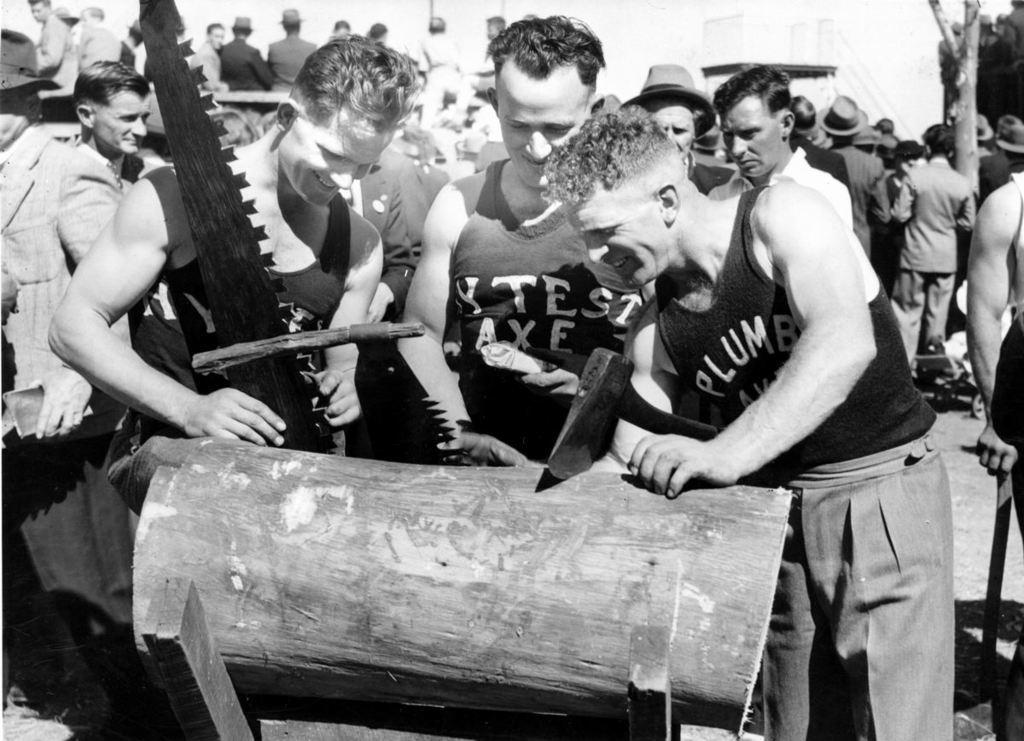How would you summarize this image in a sentence or two? This is a black and white image. In the center of the image we can see many persons standing at the wood. In the background we can see persons, building and trees. 